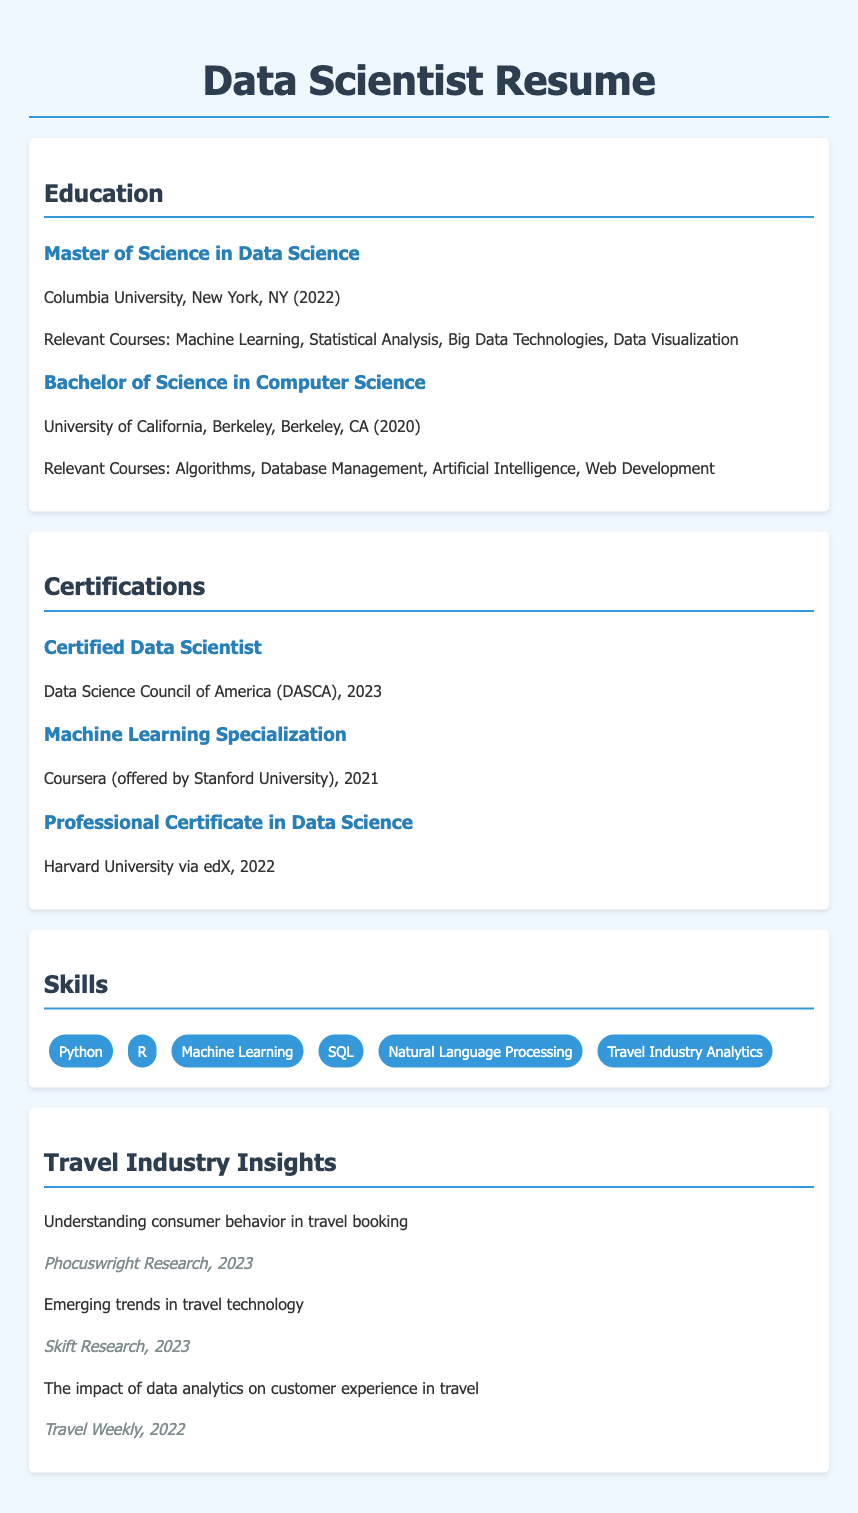what degree did the candidate earn from Columbia University? The candidate earned a Master of Science in Data Science from Columbia University.
Answer: Master of Science in Data Science when did the candidate receive the Certified Data Scientist certification? The candidate received the Certified Data Scientist certification in 2023.
Answer: 2023 which university awarded the Bachelor of Science degree? The Bachelor of Science degree was awarded by the University of California, Berkeley.
Answer: University of California, Berkeley what is one relevant course from the Master of Science program? One relevant course from the Master of Science program is Machine Learning.
Answer: Machine Learning what is the total number of travel industry insights listed? The document lists three travel industry insights.
Answer: 3 which certification is offered by Stanford University? The Machine Learning Specialization is offered by Stanford University.
Answer: Machine Learning Specialization what year did the candidate complete the Professional Certificate in Data Science from Harvard University? The candidate completed the Professional Certificate in Data Science from Harvard University in 2022.
Answer: 2022 who conducted the research on consumer behavior in travel booking? The research on consumer behavior in travel booking was conducted by Phocuswright Research.
Answer: Phocuswright Research 